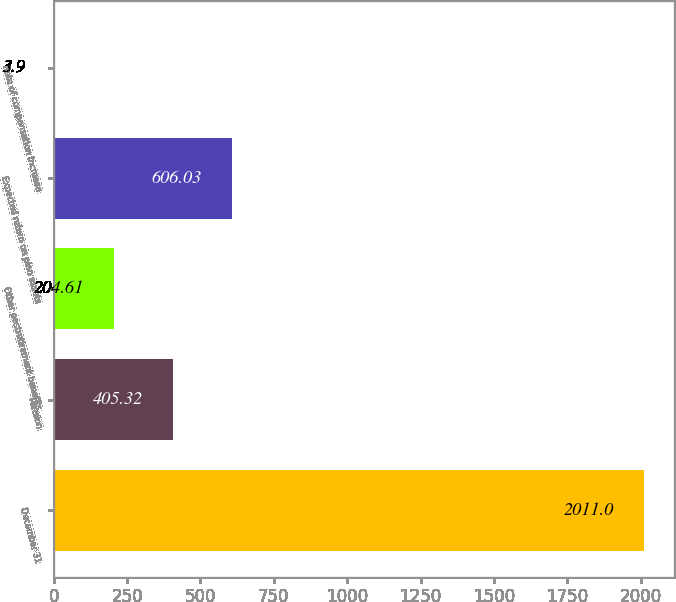Convert chart. <chart><loc_0><loc_0><loc_500><loc_500><bar_chart><fcel>December 31<fcel>Pension<fcel>Other postretirement benefits<fcel>Expected return on plan assets<fcel>Rate of compensation increase<nl><fcel>2011<fcel>405.32<fcel>204.61<fcel>606.03<fcel>3.9<nl></chart> 